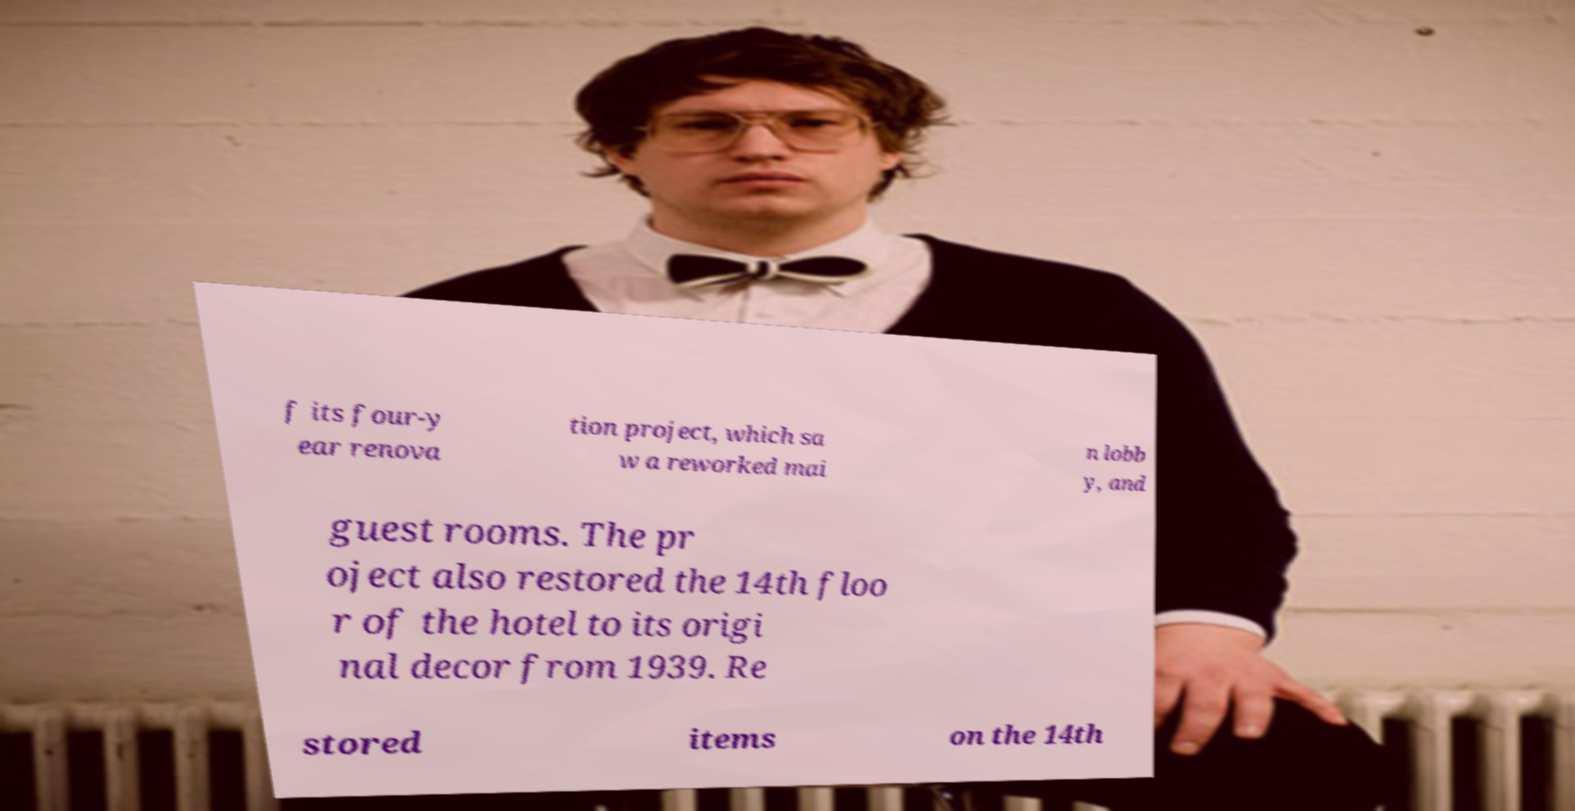Can you accurately transcribe the text from the provided image for me? f its four-y ear renova tion project, which sa w a reworked mai n lobb y, and guest rooms. The pr oject also restored the 14th floo r of the hotel to its origi nal decor from 1939. Re stored items on the 14th 